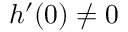Convert formula to latex. <formula><loc_0><loc_0><loc_500><loc_500>h ^ { \prime } ( 0 ) \neq 0</formula> 